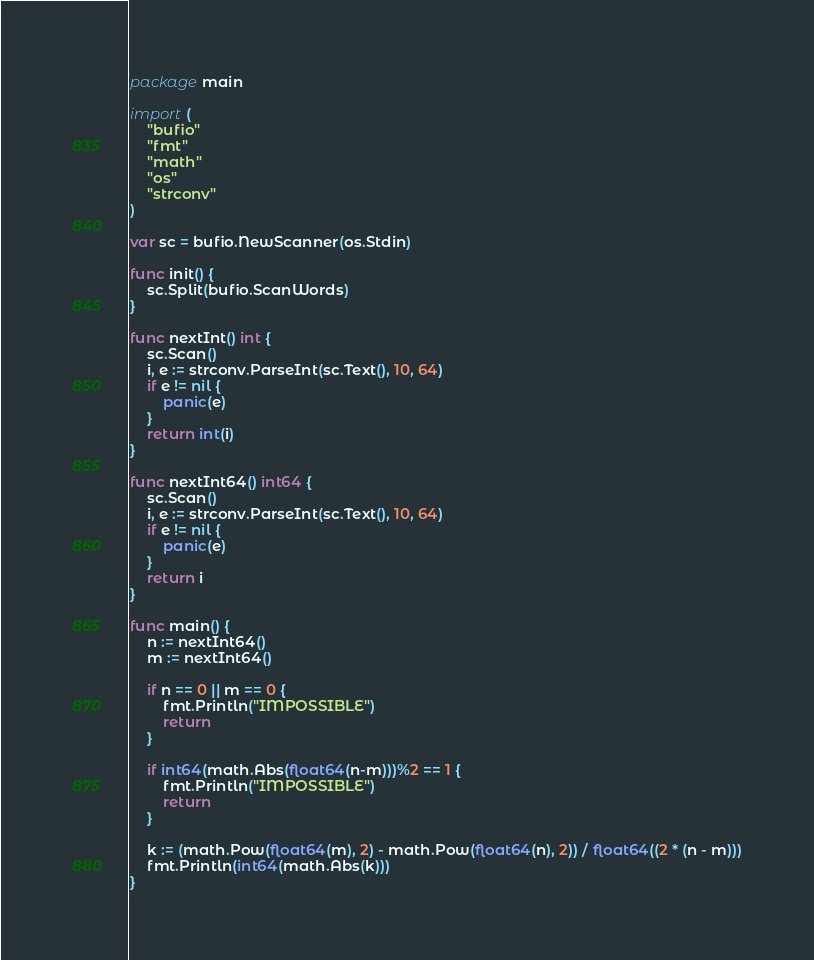Convert code to text. <code><loc_0><loc_0><loc_500><loc_500><_Go_>package main

import (
	"bufio"
	"fmt"
	"math"
	"os"
	"strconv"
)

var sc = bufio.NewScanner(os.Stdin)

func init() {
	sc.Split(bufio.ScanWords)
}

func nextInt() int {
	sc.Scan()
	i, e := strconv.ParseInt(sc.Text(), 10, 64)
	if e != nil {
		panic(e)
	}
	return int(i)
}

func nextInt64() int64 {
	sc.Scan()
	i, e := strconv.ParseInt(sc.Text(), 10, 64)
	if e != nil {
		panic(e)
	}
	return i
}

func main() {
	n := nextInt64()
	m := nextInt64()

	if n == 0 || m == 0 {
		fmt.Println("IMPOSSIBLE")
		return
	}

	if int64(math.Abs(float64(n-m)))%2 == 1 {
		fmt.Println("IMPOSSIBLE")
		return
	}

	k := (math.Pow(float64(m), 2) - math.Pow(float64(n), 2)) / float64((2 * (n - m)))
	fmt.Println(int64(math.Abs(k)))
}
</code> 